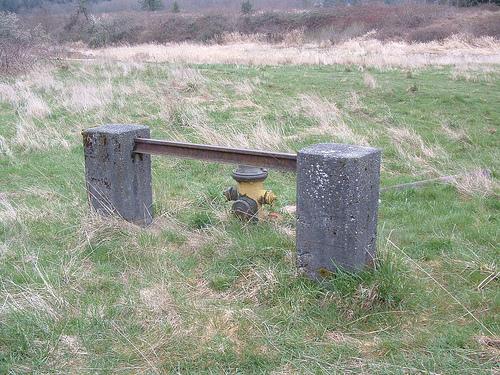What sort of location is this?
Answer briefly. Field. What color is the hydrant?
Keep it brief. Yellow. How many cement pillars are holding up the bench?
Give a very brief answer. 2. What are the barricade poles made from?
Be succinct. Concrete. What is the fence made out of?
Be succinct. Wood. 